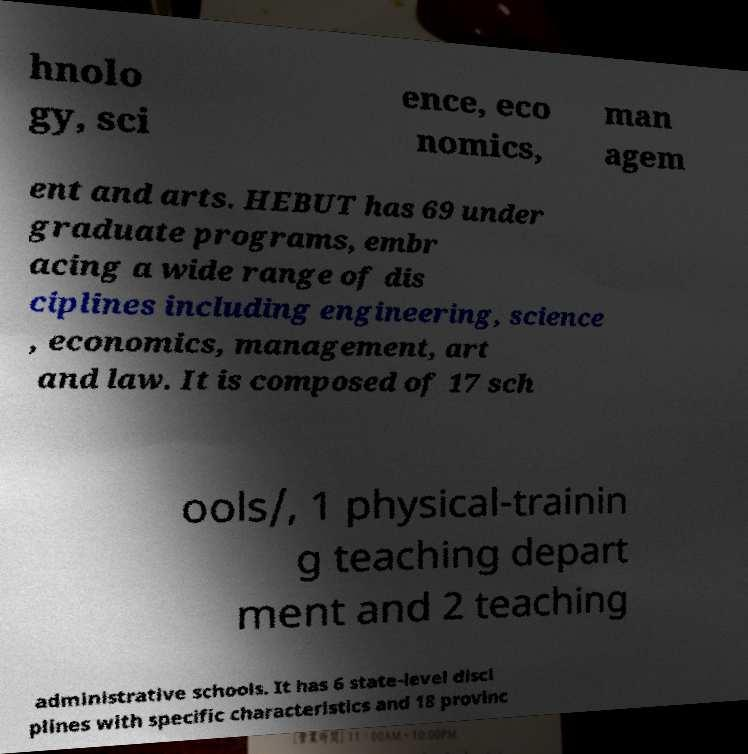What messages or text are displayed in this image? I need them in a readable, typed format. hnolo gy, sci ence, eco nomics, man agem ent and arts. HEBUT has 69 under graduate programs, embr acing a wide range of dis ciplines including engineering, science , economics, management, art and law. It is composed of 17 sch ools/, 1 physical-trainin g teaching depart ment and 2 teaching administrative schools. It has 6 state-level disci plines with specific characteristics and 18 provinc 